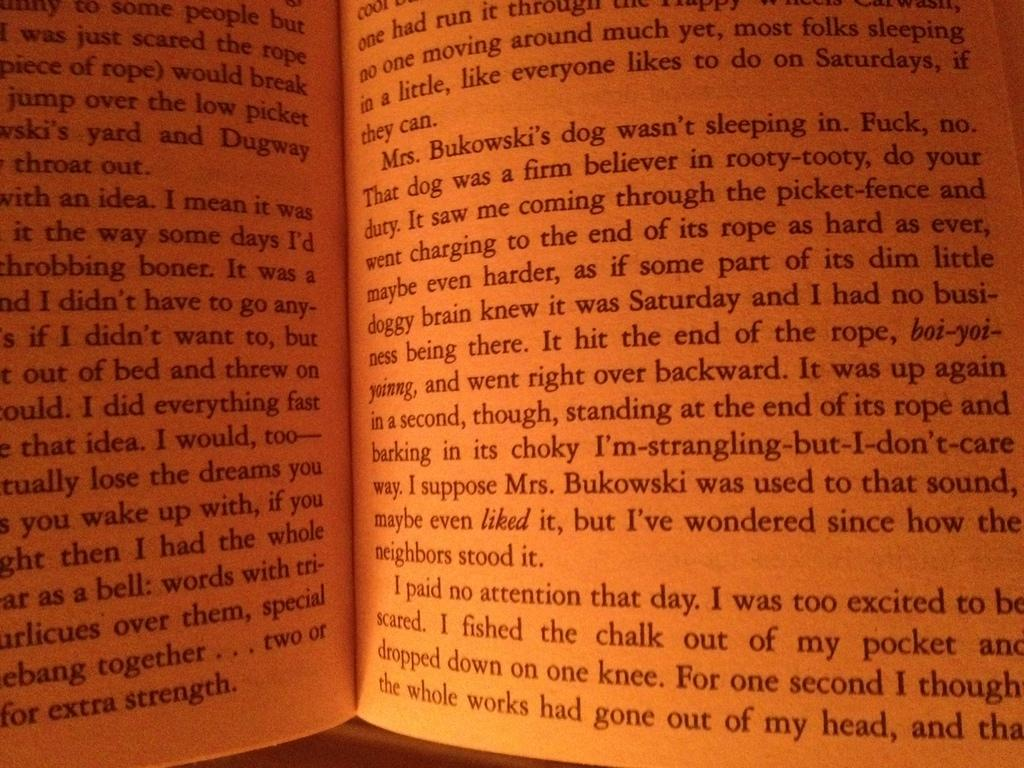<image>
Summarize the visual content of the image. Text of a book with words reading "Mrs. Bukowski's dog" 